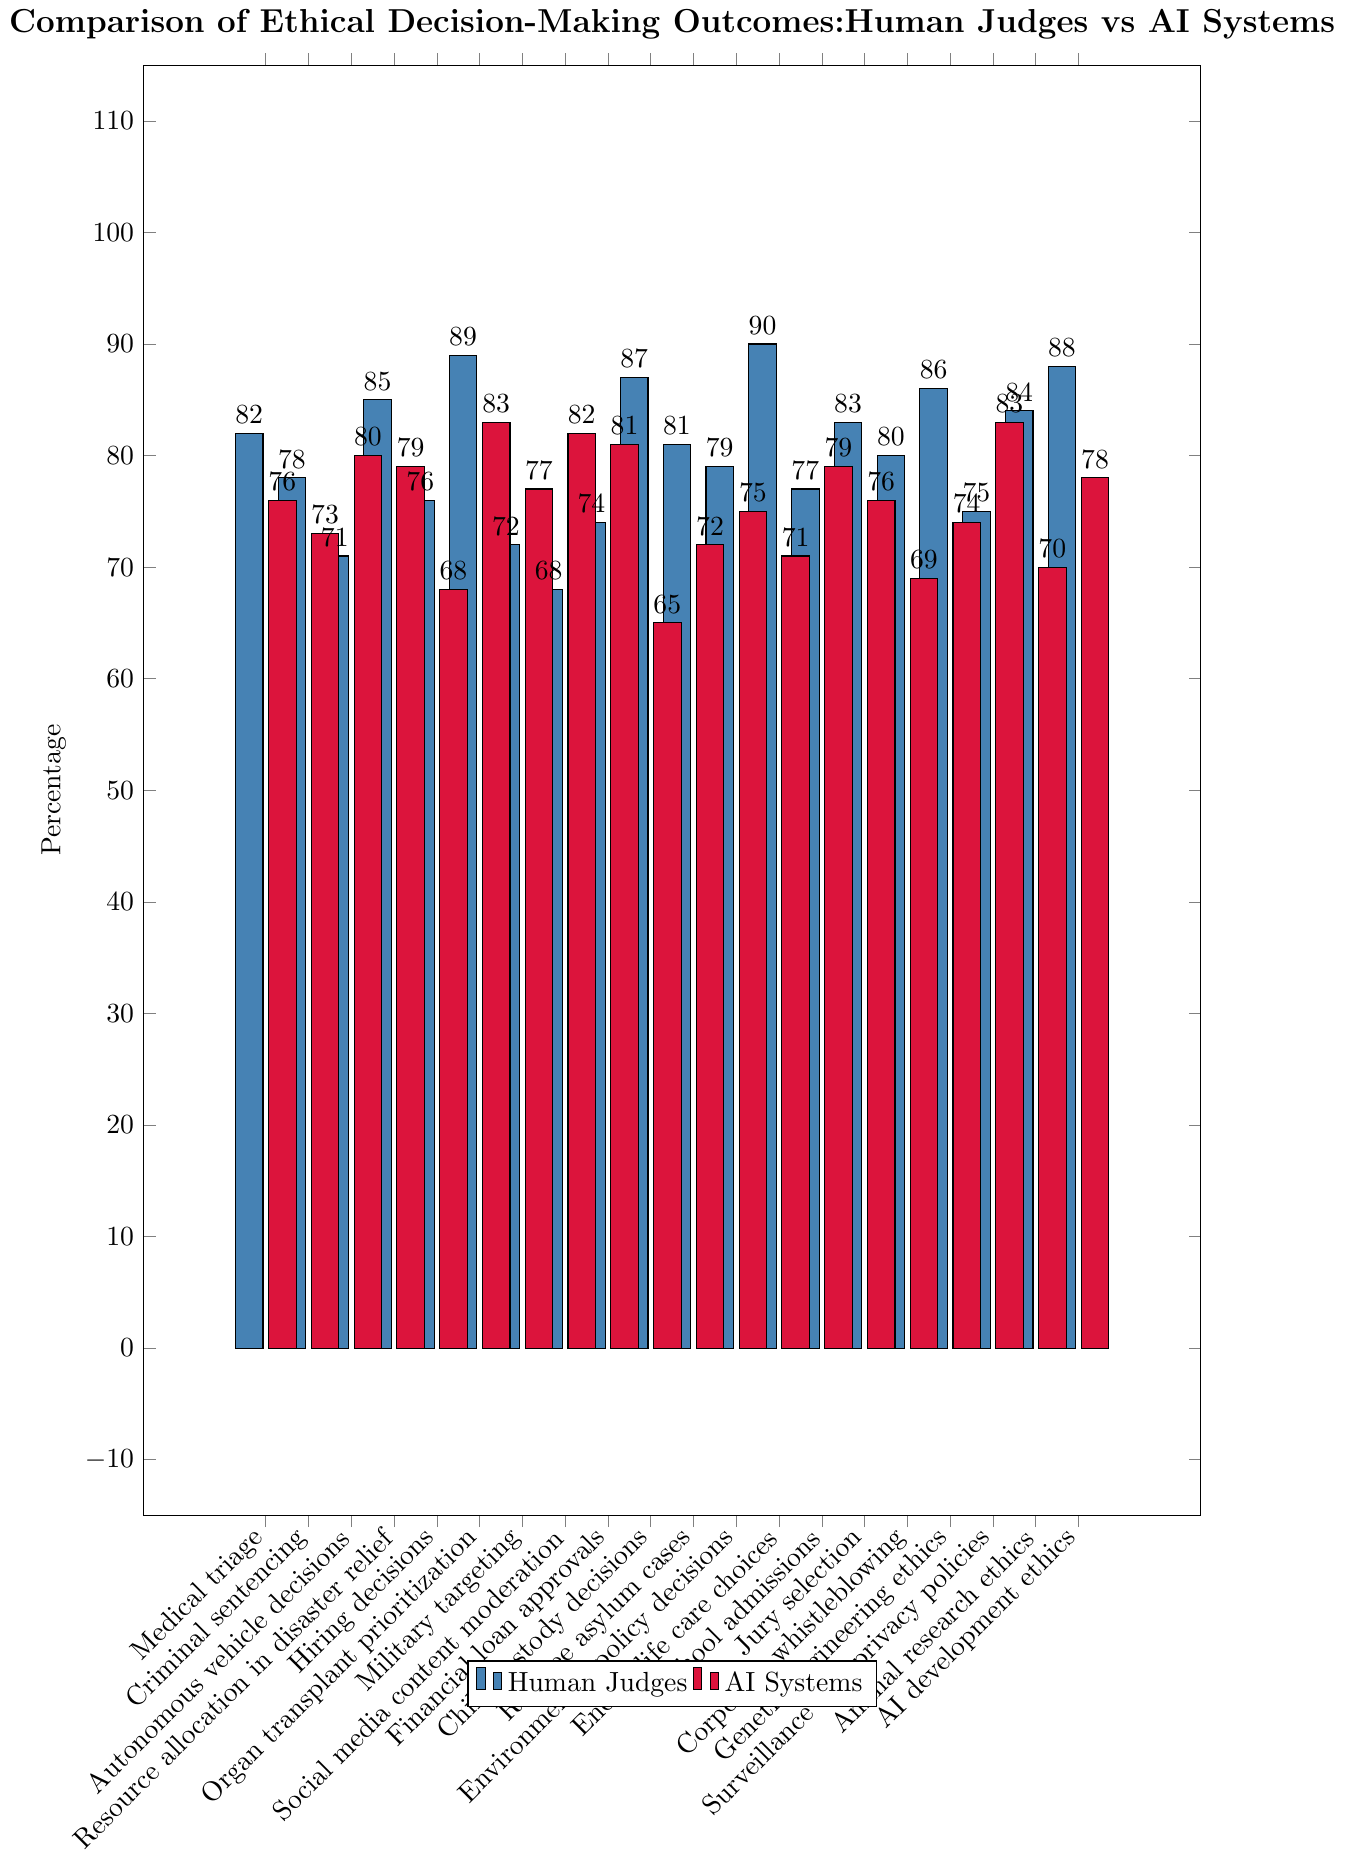What is the difference in percentage between human judges and AI systems for medical triage? Find the values for medical triage from both human judges (82%) and AI systems (76%), then calculate their difference: 82 - 76.
Answer: 6 Which scenario has the highest percentage for human judges? Look at the bar chart and identify the tallest blue bar, which corresponds to human judges. The tallest blue bar is for end-of-life care choices at 90%.
Answer: End-of-life care choices Which scenario shows the biggest gap between human judges and AI systems? Find the scenario with the largest absolute difference between the percentages of human judges and AI systems by comparing the gaps for all scenarios. The largest gap is in child custody decisions: 87% (human) - 65% (AI) = 22%.
Answer: Child custody decisions For how many scenarios does the percentage for AI systems exceed that of human judges? Count the instances where the red bar (AI systems) is higher than the blue bar (human judges). The scenarios are: autonomous vehicle decisions, social media content moderation, financial loan approvals, school admissions, and surveillance and privacy policies, which make a total of 5 scenarios.
Answer: 5 What is the average percentage for AI systems across all scenarios? Sum up all percentages for AI systems and divide by the number of scenarios: (76 + 73 + 80 + 79 + 68 + 83 + 77 + 82 + 81 + 65 + 72 + 75 + 71 + 79 + 76 + 69 + 74 + 83 + 70 + 78) / 20 = 75.25
Answer: 75.25 Which scenario(s) have equal percentages for human judges and AI systems? Compare the values for human judges and AI systems and find the scenario(s) where these percentages match. The only scenario with equal percentages is school admissions at 79%.
Answer: School admissions What is the percentage difference for organ transplant prioritization between human judges and AI systems? Find the values for organ transplant prioritization from both human judges (89%) and AI systems (83%), then calculate their difference: 89 - 83 = 6.
Answer: 6 What are the percentages for AI systems in financial loan approvals and child custody decisions? Which one is higher? Refer to the bar chart and look for the height of the red bars in financial loan approvals (81%) and child custody decisions (65%). Financial loan approvals have a higher percentage for AI systems.
Answer: Financial loan approvals is higher (81%) What is the median percentage for AI systems across all scenarios? Arrange the percentages of AI systems in ascending order and find the middle value(s). If there is an even number of data points, take the average of the two middle values. The sorted percentages are: 65, 68, 69, 70, 71, 72, 73, 74, 75, 76, 76, 77, 78, 79, 79, 80, 81, 82, 83, 83. The middle values are 76 and 77, so the median is (76 + 77) / 2 = 76.5.
Answer: 76.5 Which two scenarios have the closest percentages for AI systems and what are their values? Identify scenarios with the smallest absolute difference in percentages for AI systems. Financial loan approvals and surveillance and privacy policies both have 83%, making their values the closest.
Answer: Financial loan approvals and surveillance and privacy policies (83%) 